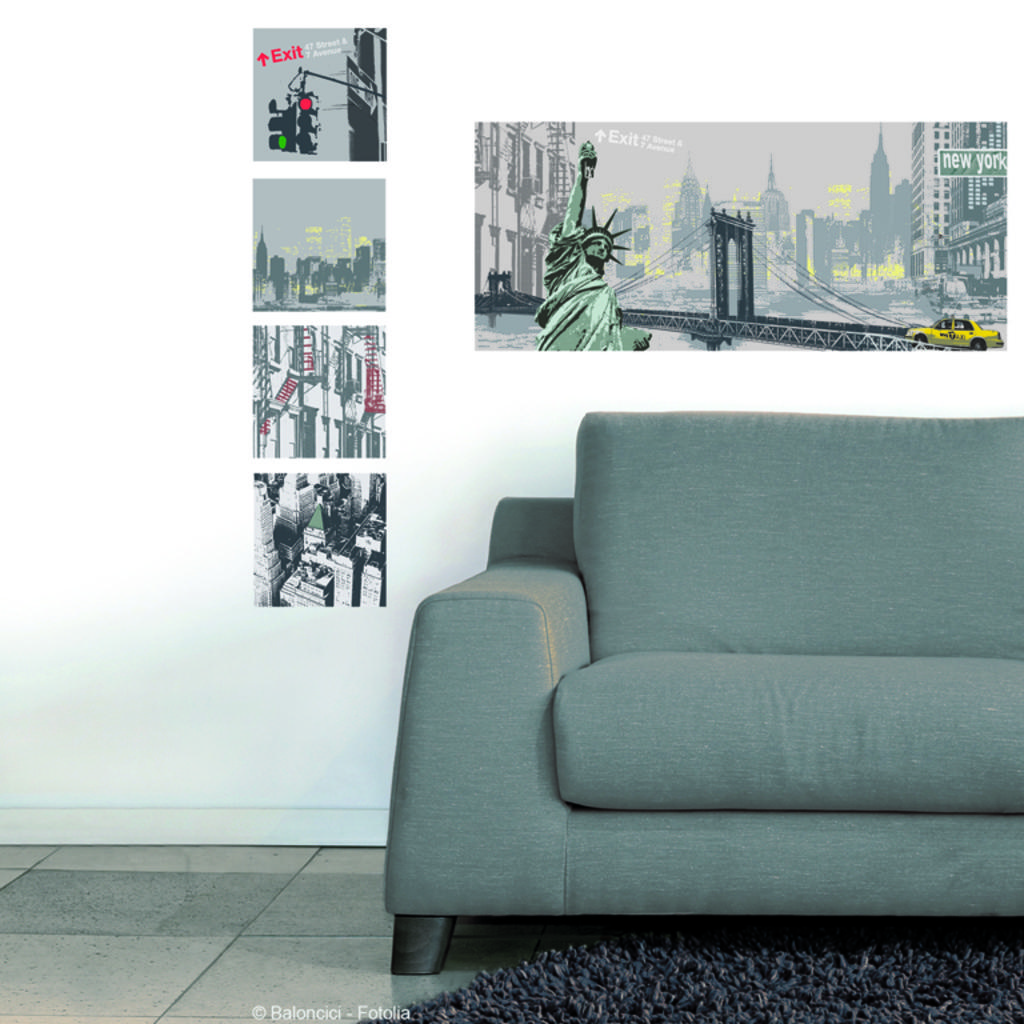What is the color and pattern of the wallpaper in the image? The wallpaper in the image is white and has a pattern. What type of furniture is present in the image? There is a sofa in the image. How many geese are sitting on the sofa in the image? There are no geese present in the image; it only features a sofa and wallpaper. 